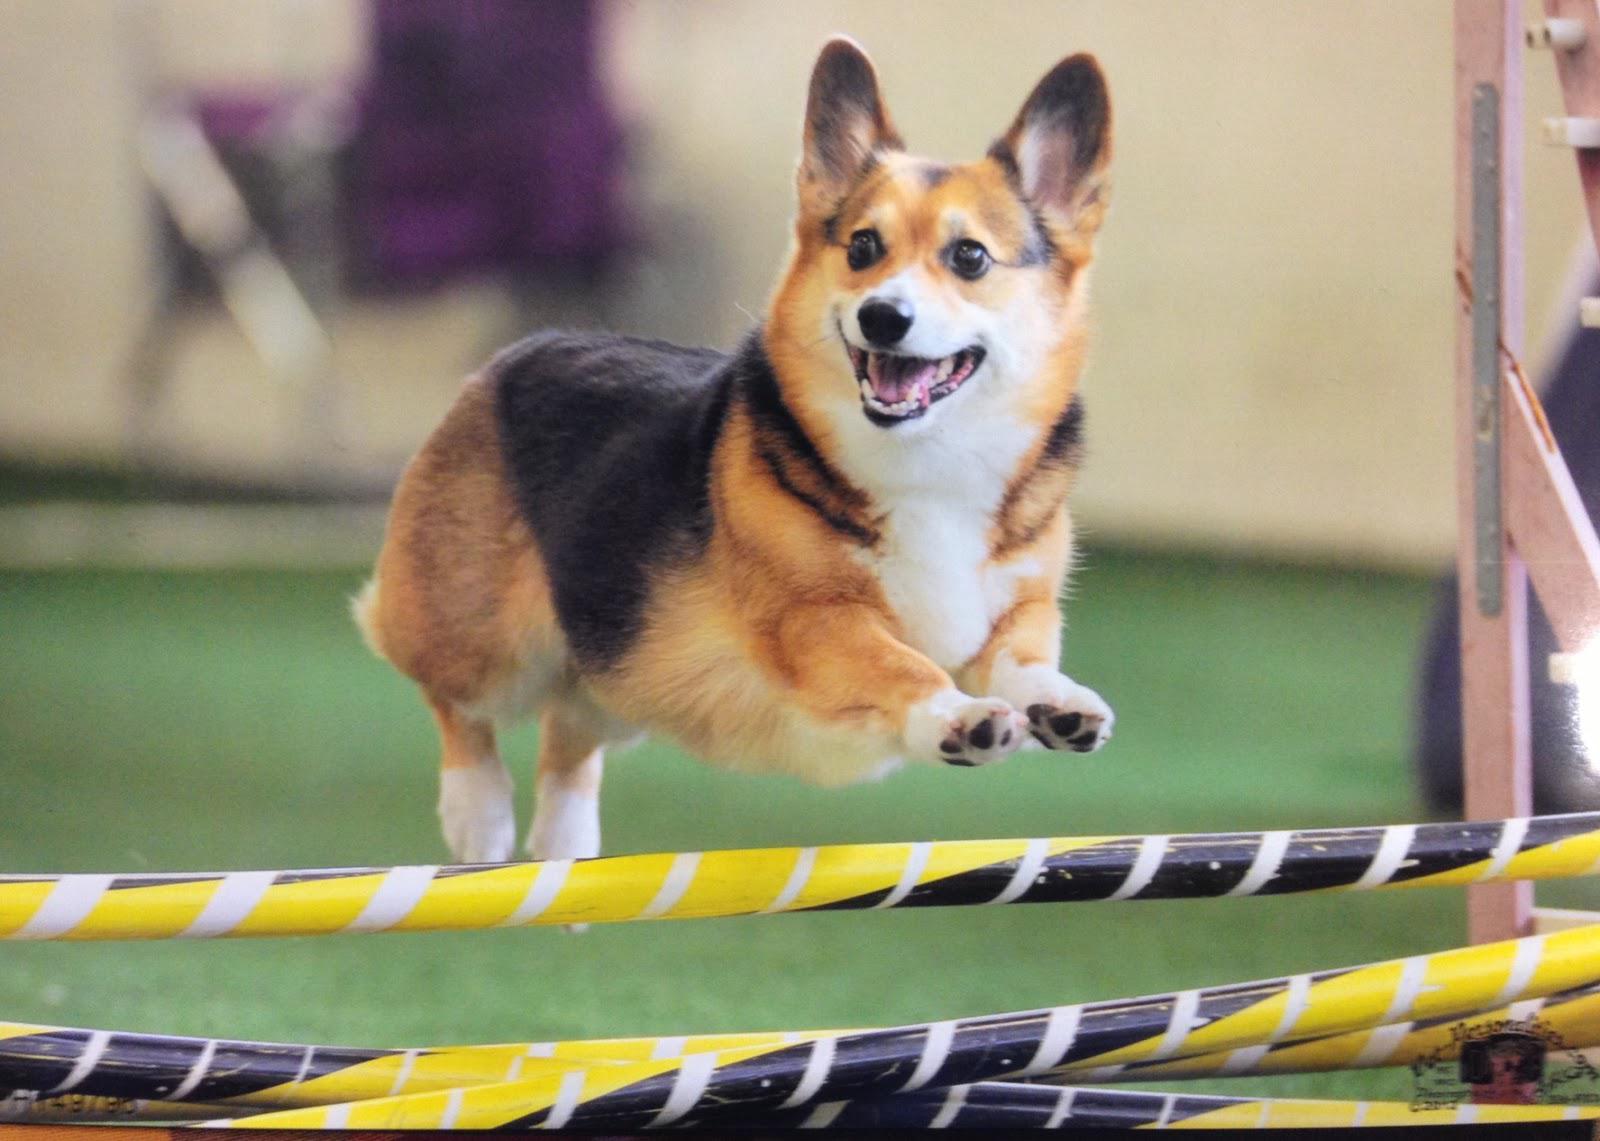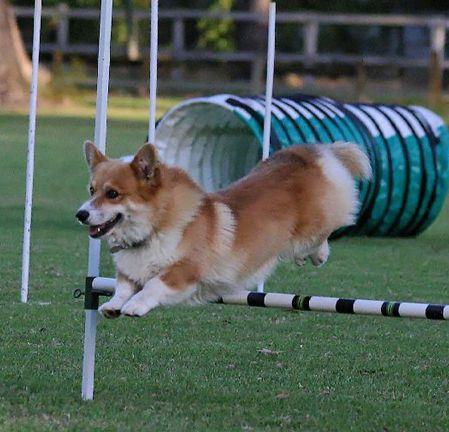The first image is the image on the left, the second image is the image on the right. Evaluate the accuracy of this statement regarding the images: "The dog in the right image is inside of a small inflatable swimming pool.". Is it true? Answer yes or no. No. The first image is the image on the left, the second image is the image on the right. Evaluate the accuracy of this statement regarding the images: "No less than one dog is in mid air jumping over a hurdle". Is it true? Answer yes or no. Yes. 